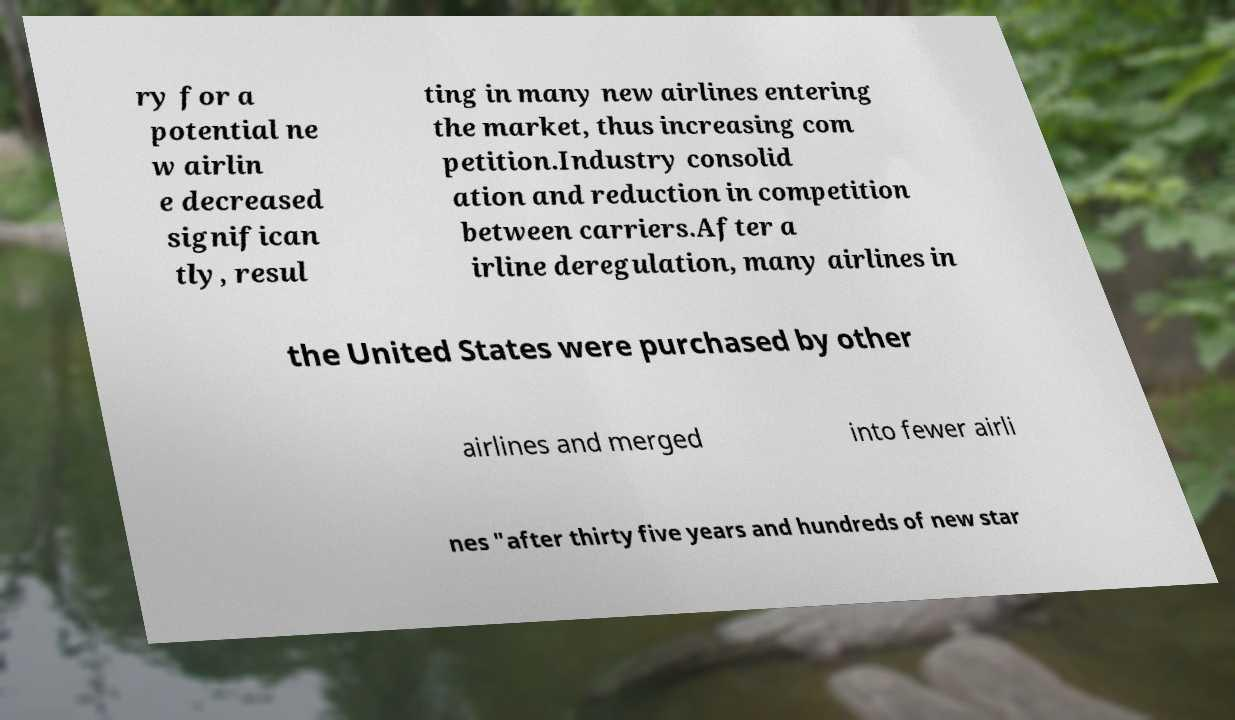Could you extract and type out the text from this image? ry for a potential ne w airlin e decreased significan tly, resul ting in many new airlines entering the market, thus increasing com petition.Industry consolid ation and reduction in competition between carriers.After a irline deregulation, many airlines in the United States were purchased by other airlines and merged into fewer airli nes "after thirty five years and hundreds of new star 